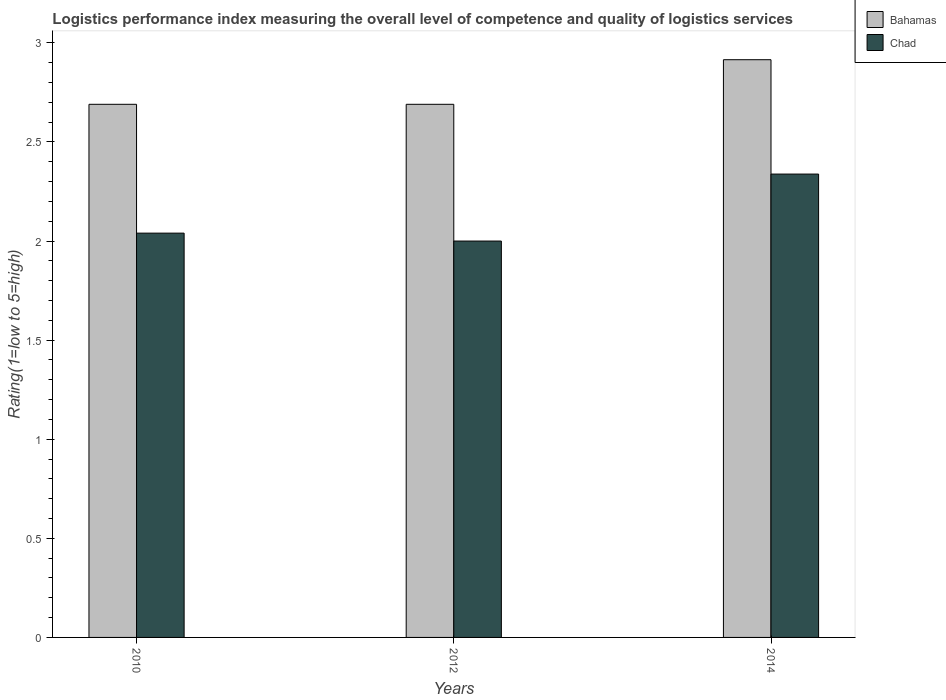How many groups of bars are there?
Your response must be concise. 3. In how many cases, is the number of bars for a given year not equal to the number of legend labels?
Your response must be concise. 0. Across all years, what is the maximum Logistic performance index in Bahamas?
Provide a short and direct response. 2.92. Across all years, what is the minimum Logistic performance index in Bahamas?
Offer a very short reply. 2.69. In which year was the Logistic performance index in Chad maximum?
Provide a succinct answer. 2014. What is the total Logistic performance index in Bahamas in the graph?
Your answer should be compact. 8.3. What is the difference between the Logistic performance index in Chad in 2010 and that in 2012?
Give a very brief answer. 0.04. What is the difference between the Logistic performance index in Bahamas in 2010 and the Logistic performance index in Chad in 2012?
Your answer should be very brief. 0.69. What is the average Logistic performance index in Chad per year?
Provide a succinct answer. 2.13. In the year 2012, what is the difference between the Logistic performance index in Chad and Logistic performance index in Bahamas?
Offer a very short reply. -0.69. What is the ratio of the Logistic performance index in Bahamas in 2012 to that in 2014?
Provide a succinct answer. 0.92. What is the difference between the highest and the second highest Logistic performance index in Chad?
Give a very brief answer. 0.3. What is the difference between the highest and the lowest Logistic performance index in Bahamas?
Your answer should be very brief. 0.23. What does the 1st bar from the left in 2010 represents?
Your answer should be compact. Bahamas. What does the 2nd bar from the right in 2012 represents?
Make the answer very short. Bahamas. How many years are there in the graph?
Provide a short and direct response. 3. Does the graph contain grids?
Ensure brevity in your answer.  No. How many legend labels are there?
Provide a succinct answer. 2. What is the title of the graph?
Provide a succinct answer. Logistics performance index measuring the overall level of competence and quality of logistics services. What is the label or title of the X-axis?
Your answer should be very brief. Years. What is the label or title of the Y-axis?
Keep it short and to the point. Rating(1=low to 5=high). What is the Rating(1=low to 5=high) in Bahamas in 2010?
Provide a succinct answer. 2.69. What is the Rating(1=low to 5=high) of Chad in 2010?
Keep it short and to the point. 2.04. What is the Rating(1=low to 5=high) of Bahamas in 2012?
Your answer should be very brief. 2.69. What is the Rating(1=low to 5=high) of Chad in 2012?
Keep it short and to the point. 2. What is the Rating(1=low to 5=high) in Bahamas in 2014?
Offer a very short reply. 2.92. What is the Rating(1=low to 5=high) in Chad in 2014?
Your answer should be compact. 2.34. Across all years, what is the maximum Rating(1=low to 5=high) in Bahamas?
Your answer should be very brief. 2.92. Across all years, what is the maximum Rating(1=low to 5=high) of Chad?
Your answer should be very brief. 2.34. Across all years, what is the minimum Rating(1=low to 5=high) in Bahamas?
Give a very brief answer. 2.69. Across all years, what is the minimum Rating(1=low to 5=high) in Chad?
Offer a terse response. 2. What is the total Rating(1=low to 5=high) in Bahamas in the graph?
Offer a terse response. 8.29. What is the total Rating(1=low to 5=high) in Chad in the graph?
Your answer should be compact. 6.38. What is the difference between the Rating(1=low to 5=high) of Chad in 2010 and that in 2012?
Provide a short and direct response. 0.04. What is the difference between the Rating(1=low to 5=high) in Bahamas in 2010 and that in 2014?
Give a very brief answer. -0.23. What is the difference between the Rating(1=low to 5=high) in Chad in 2010 and that in 2014?
Provide a short and direct response. -0.3. What is the difference between the Rating(1=low to 5=high) in Bahamas in 2012 and that in 2014?
Give a very brief answer. -0.23. What is the difference between the Rating(1=low to 5=high) in Chad in 2012 and that in 2014?
Provide a succinct answer. -0.34. What is the difference between the Rating(1=low to 5=high) in Bahamas in 2010 and the Rating(1=low to 5=high) in Chad in 2012?
Keep it short and to the point. 0.69. What is the difference between the Rating(1=low to 5=high) of Bahamas in 2010 and the Rating(1=low to 5=high) of Chad in 2014?
Ensure brevity in your answer.  0.35. What is the difference between the Rating(1=low to 5=high) in Bahamas in 2012 and the Rating(1=low to 5=high) in Chad in 2014?
Your response must be concise. 0.35. What is the average Rating(1=low to 5=high) of Bahamas per year?
Offer a very short reply. 2.77. What is the average Rating(1=low to 5=high) of Chad per year?
Offer a very short reply. 2.13. In the year 2010, what is the difference between the Rating(1=low to 5=high) in Bahamas and Rating(1=low to 5=high) in Chad?
Your response must be concise. 0.65. In the year 2012, what is the difference between the Rating(1=low to 5=high) in Bahamas and Rating(1=low to 5=high) in Chad?
Your response must be concise. 0.69. In the year 2014, what is the difference between the Rating(1=low to 5=high) in Bahamas and Rating(1=low to 5=high) in Chad?
Provide a succinct answer. 0.58. What is the ratio of the Rating(1=low to 5=high) of Chad in 2010 to that in 2012?
Make the answer very short. 1.02. What is the ratio of the Rating(1=low to 5=high) in Bahamas in 2010 to that in 2014?
Give a very brief answer. 0.92. What is the ratio of the Rating(1=low to 5=high) of Chad in 2010 to that in 2014?
Your response must be concise. 0.87. What is the ratio of the Rating(1=low to 5=high) of Bahamas in 2012 to that in 2014?
Keep it short and to the point. 0.92. What is the ratio of the Rating(1=low to 5=high) of Chad in 2012 to that in 2014?
Offer a terse response. 0.86. What is the difference between the highest and the second highest Rating(1=low to 5=high) in Bahamas?
Your answer should be very brief. 0.23. What is the difference between the highest and the second highest Rating(1=low to 5=high) of Chad?
Offer a terse response. 0.3. What is the difference between the highest and the lowest Rating(1=low to 5=high) of Bahamas?
Ensure brevity in your answer.  0.23. What is the difference between the highest and the lowest Rating(1=low to 5=high) of Chad?
Your answer should be very brief. 0.34. 